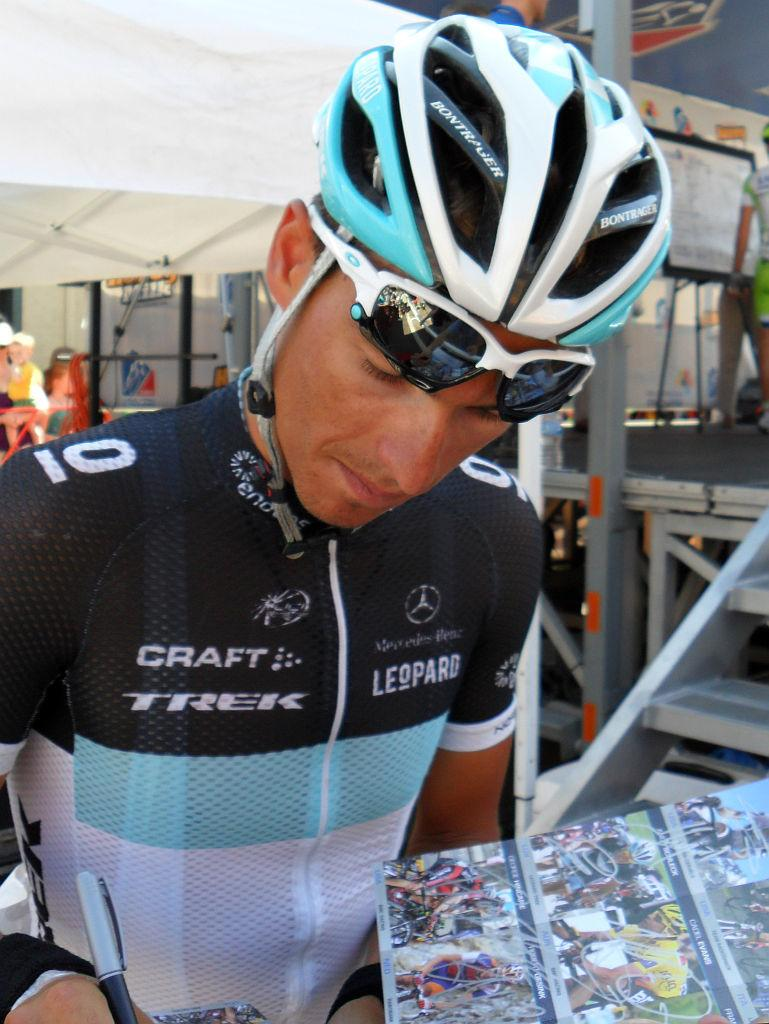What is the person in the image doing? The person is writing with a pen. What protective gear is the person wearing? The person is wearing goggles and a helmet. What is in front of the person? There is a book with photos in front of the person. What can be seen in the background of the image? There are steps and poles in the background of the image. How much wealth does the ladybug in the image possess? There is no ladybug present in the image, so it is not possible to determine its wealth. 